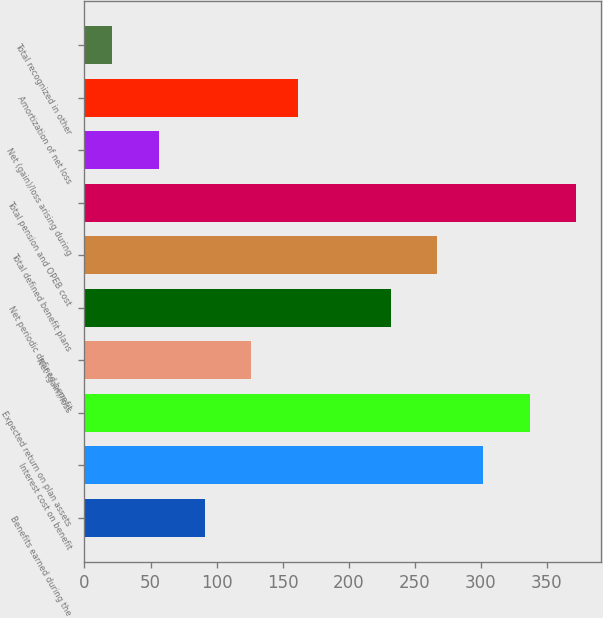Convert chart to OTSL. <chart><loc_0><loc_0><loc_500><loc_500><bar_chart><fcel>Benefits earned during the<fcel>Interest cost on benefit<fcel>Expected return on plan assets<fcel>Net (gain)/loss<fcel>Net periodic defined benefit<fcel>Total defined benefit plans<fcel>Total pension and OPEB cost<fcel>Net (gain)/loss arising during<fcel>Amortization of net loss<fcel>Total recognized in other<nl><fcel>91.2<fcel>301.8<fcel>336.9<fcel>126.3<fcel>231.6<fcel>266.7<fcel>372<fcel>56.1<fcel>161.4<fcel>21<nl></chart> 